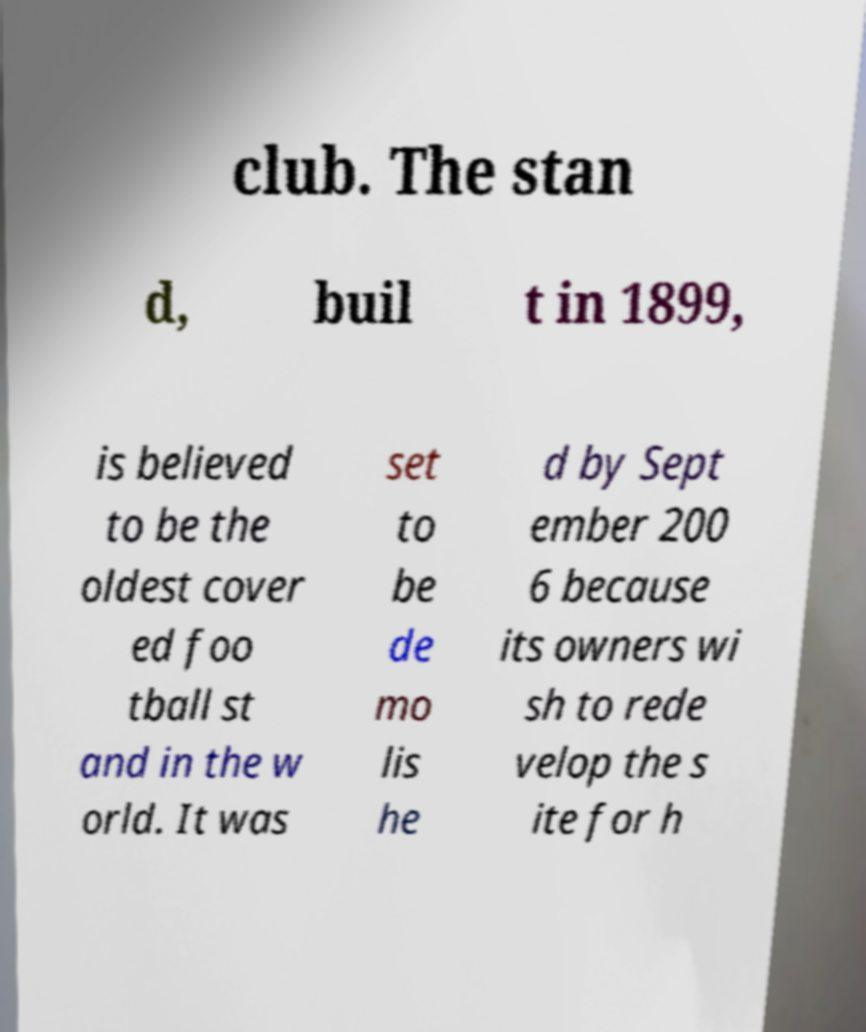Can you accurately transcribe the text from the provided image for me? club. The stan d, buil t in 1899, is believed to be the oldest cover ed foo tball st and in the w orld. It was set to be de mo lis he d by Sept ember 200 6 because its owners wi sh to rede velop the s ite for h 